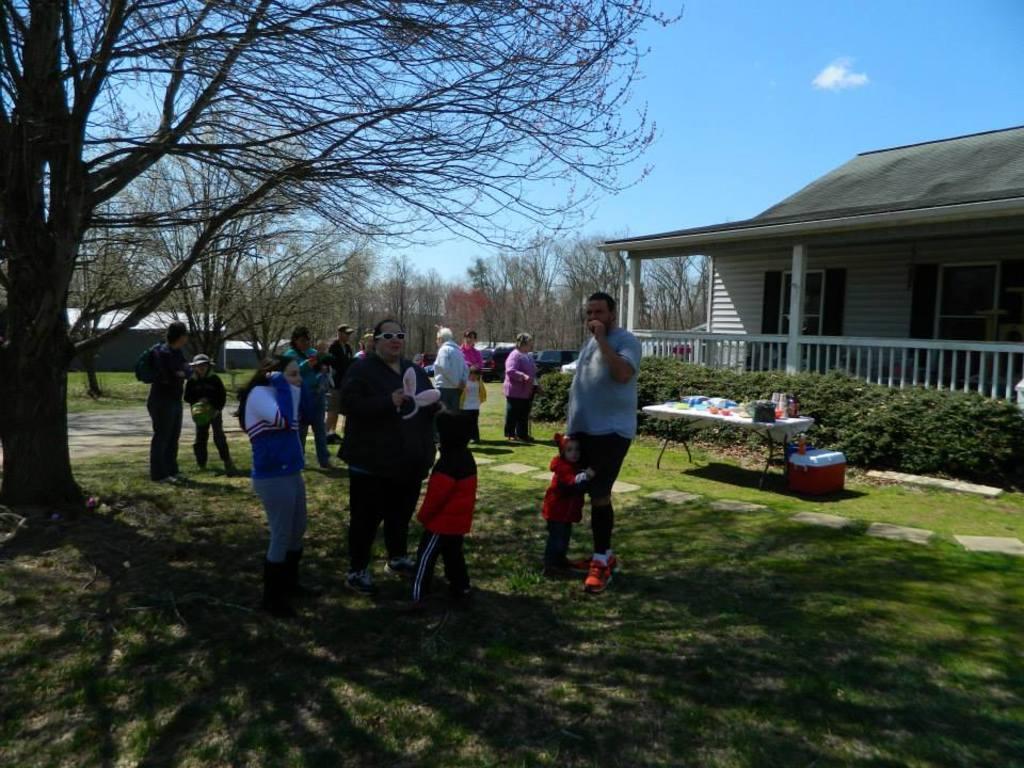How would you summarize this image in a sentence or two? In the foreground of this image, there are people standing on the grass land. On the left, there is a tree. On the right, there is a house, few plants, few objects on the table and a red basket on the grass land. In the background, there are trees, shed, few vehicles, sky and the cloud. 